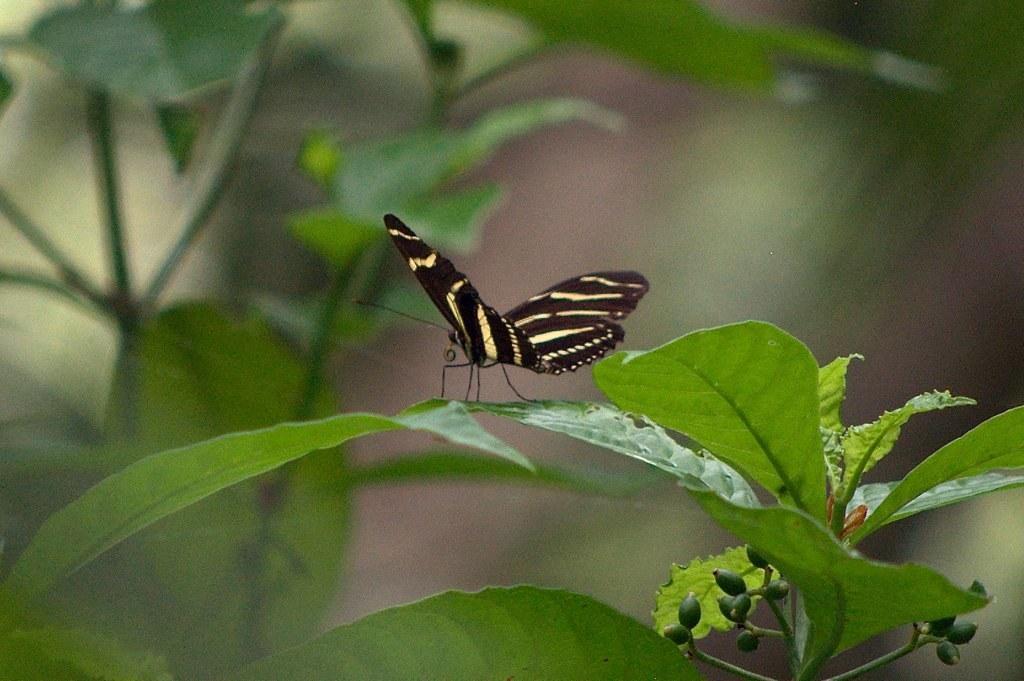Describe this image in one or two sentences. In this picture there is a black and yellow color butterfly sitting on the green leaf. Behind there is a blur background. 